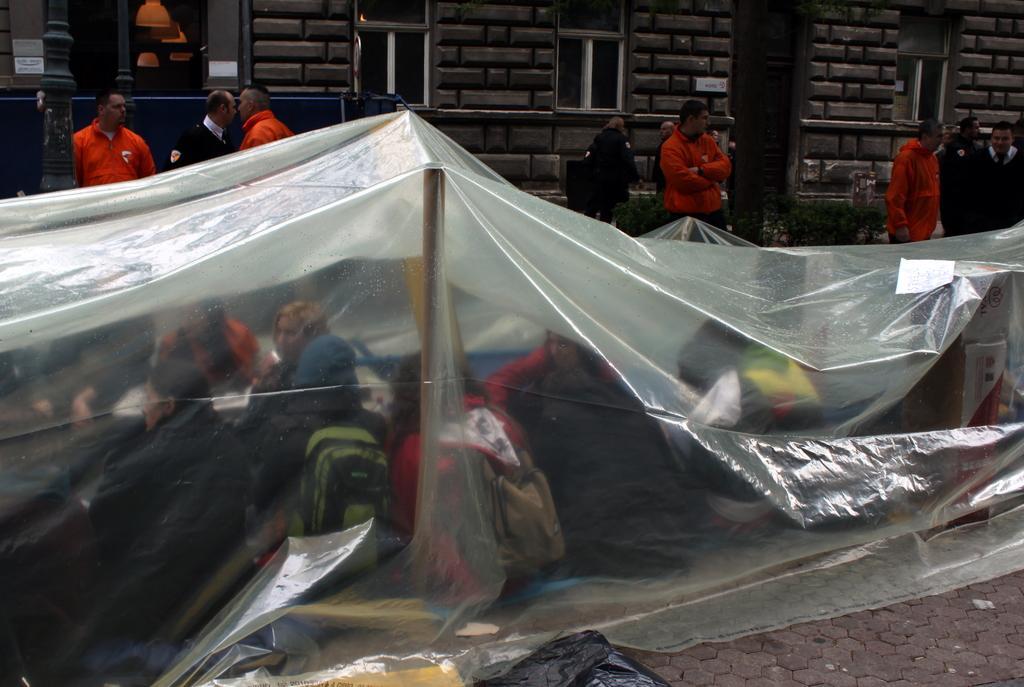Please provide a concise description of this image. In this image we can see a few people, some of them are sitting under the cover, few people are wearing backpacks, there are windows, also we can see a pole, and the wall. 